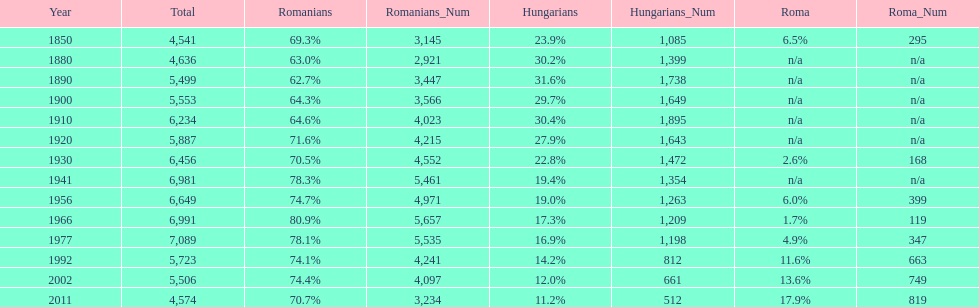Which year had a total of 6,981 and 19.4% hungarians? 1941. 